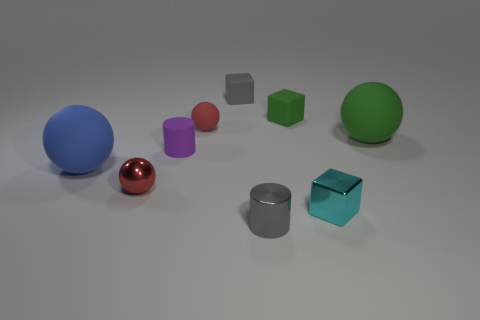Subtract all green spheres. Subtract all red cylinders. How many spheres are left? 3 Subtract all spheres. How many objects are left? 5 Subtract 1 blue spheres. How many objects are left? 8 Subtract all blue rubber objects. Subtract all cyan shiny things. How many objects are left? 7 Add 1 blue rubber spheres. How many blue rubber spheres are left? 2 Add 5 small metallic spheres. How many small metallic spheres exist? 6 